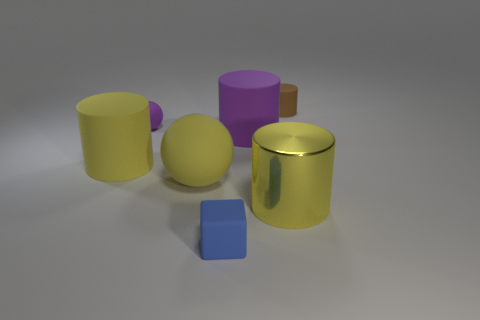There is a yellow object that is the same material as the yellow sphere; what shape is it?
Provide a short and direct response. Cylinder. Is the material of the brown cylinder the same as the large cylinder that is in front of the yellow rubber cylinder?
Your answer should be compact. No. There is a tiny thing behind the tiny purple object; is its shape the same as the big purple object?
Your answer should be compact. Yes. There is a brown thing; is its shape the same as the purple object that is to the left of the small cube?
Provide a short and direct response. No. There is a thing that is both to the right of the small purple rubber ball and on the left side of the matte block; what color is it?
Give a very brief answer. Yellow. Is there a gray rubber sphere?
Offer a very short reply. No. Are there an equal number of large yellow shiny cylinders to the left of the large yellow metal cylinder and small yellow metallic cubes?
Ensure brevity in your answer.  Yes. What number of other objects are there of the same shape as the blue matte thing?
Provide a short and direct response. 0. What is the shape of the small brown thing?
Your answer should be compact. Cylinder. Are the big purple cylinder and the brown thing made of the same material?
Keep it short and to the point. Yes. 